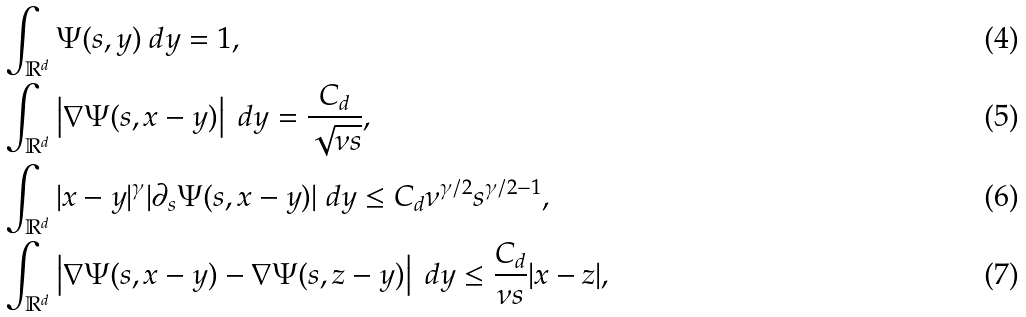<formula> <loc_0><loc_0><loc_500><loc_500>& \int _ { \mathbb { R } ^ { d } } \Psi ( s , y ) \ d y = 1 , \\ & \int _ { \mathbb { R } ^ { d } } \left | \nabla \Psi ( s , x - y ) \right | \ d y = \frac { C _ { d } } { \sqrt { \nu s } } , \\ & \int _ { \mathbb { R } ^ { d } } | x - y | ^ { \gamma } | \partial _ { s } \Psi ( s , x - y ) | \ d y \leq C _ { d } \nu ^ { \gamma / 2 } s ^ { \gamma / 2 - 1 } , \\ & \int _ { \mathbb { R } ^ { d } } \left | \nabla \Psi ( s , x - y ) - \nabla \Psi ( s , z - y ) \right | \ d y \leq \frac { C _ { d } } { \nu s } | x - z | ,</formula> 